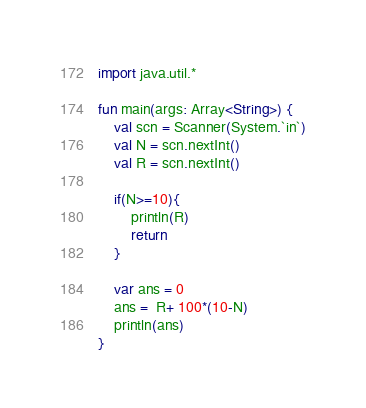<code> <loc_0><loc_0><loc_500><loc_500><_Kotlin_>import java.util.*

fun main(args: Array<String>) {
    val scn = Scanner(System.`in`)
    val N = scn.nextInt()
    val R = scn.nextInt()

    if(N>=10){
        println(R)
        return
    }

    var ans = 0
    ans =  R+ 100*(10-N)
    println(ans)
}</code> 